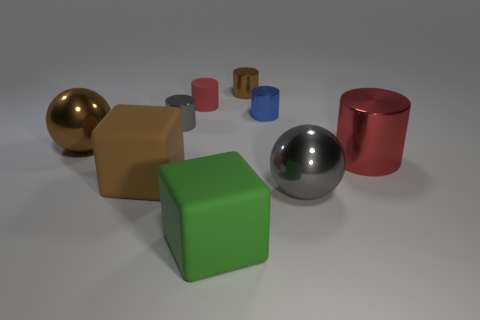What color is the rubber cube that is on the left side of the gray cylinder?
Offer a very short reply. Brown. Is there a gray thing that is behind the tiny brown metal cylinder behind the gray metal cylinder?
Offer a terse response. No. There is a big brown thing that is in front of the large ball that is to the left of the gray ball; what is it made of?
Your answer should be very brief. Rubber. Is the number of metallic objects left of the rubber cylinder the same as the number of red metallic objects that are right of the tiny brown metallic thing?
Make the answer very short. No. What number of things are either shiny objects that are left of the small gray cylinder or large metal spheres behind the gray ball?
Keep it short and to the point. 1. There is a big object that is both behind the large brown matte thing and to the right of the tiny red matte cylinder; what material is it?
Offer a very short reply. Metal. There is a cylinder that is behind the red object that is to the left of the brown metal object that is to the right of the green matte block; what is its size?
Keep it short and to the point. Small. Do the small object to the right of the tiny brown cylinder and the brown sphere have the same material?
Offer a very short reply. Yes. There is a small metal thing on the left side of the small shiny cylinder behind the tiny red rubber cylinder; are there any large rubber objects behind it?
Your response must be concise. No. There is a gray metal thing that is behind the brown block; is it the same shape as the big brown rubber thing?
Ensure brevity in your answer.  No. 